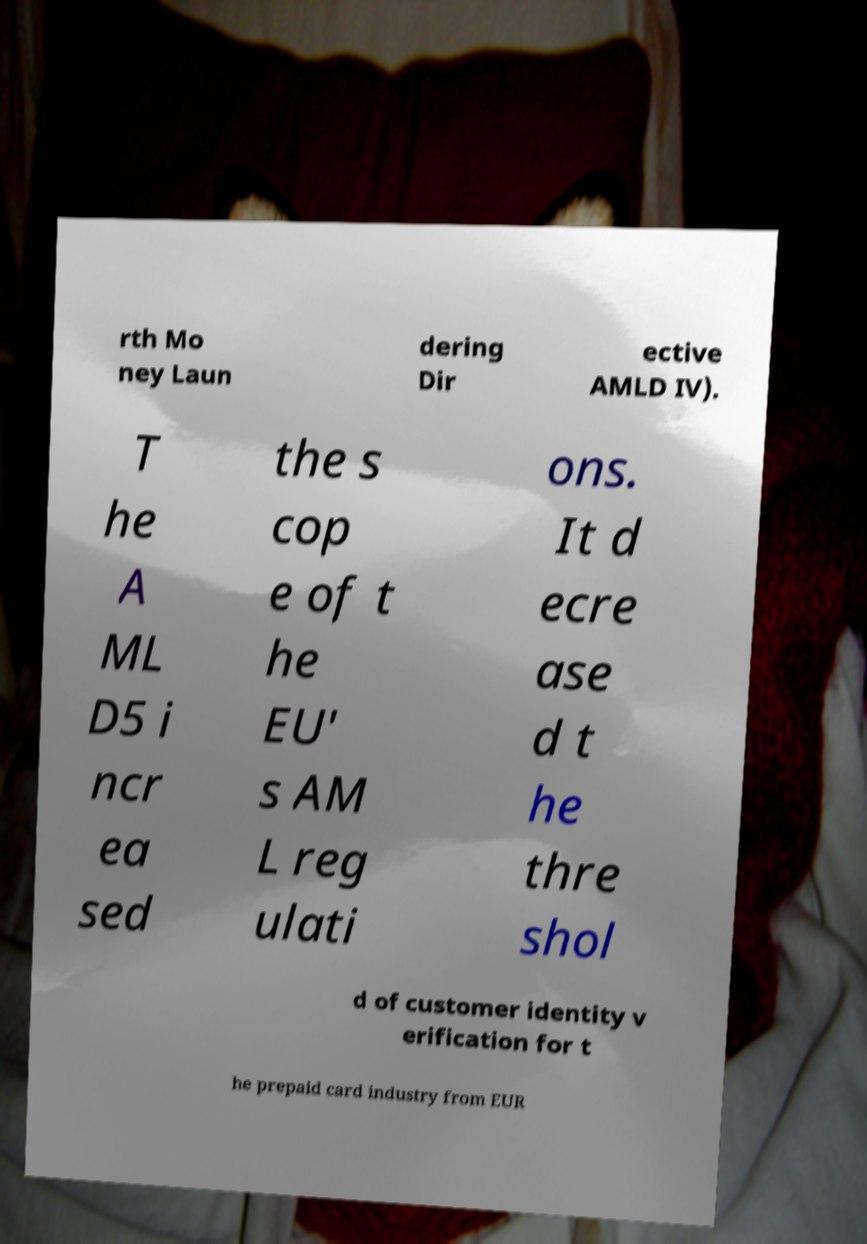Can you accurately transcribe the text from the provided image for me? rth Mo ney Laun dering Dir ective AMLD IV). T he A ML D5 i ncr ea sed the s cop e of t he EU' s AM L reg ulati ons. It d ecre ase d t he thre shol d of customer identity v erification for t he prepaid card industry from EUR 